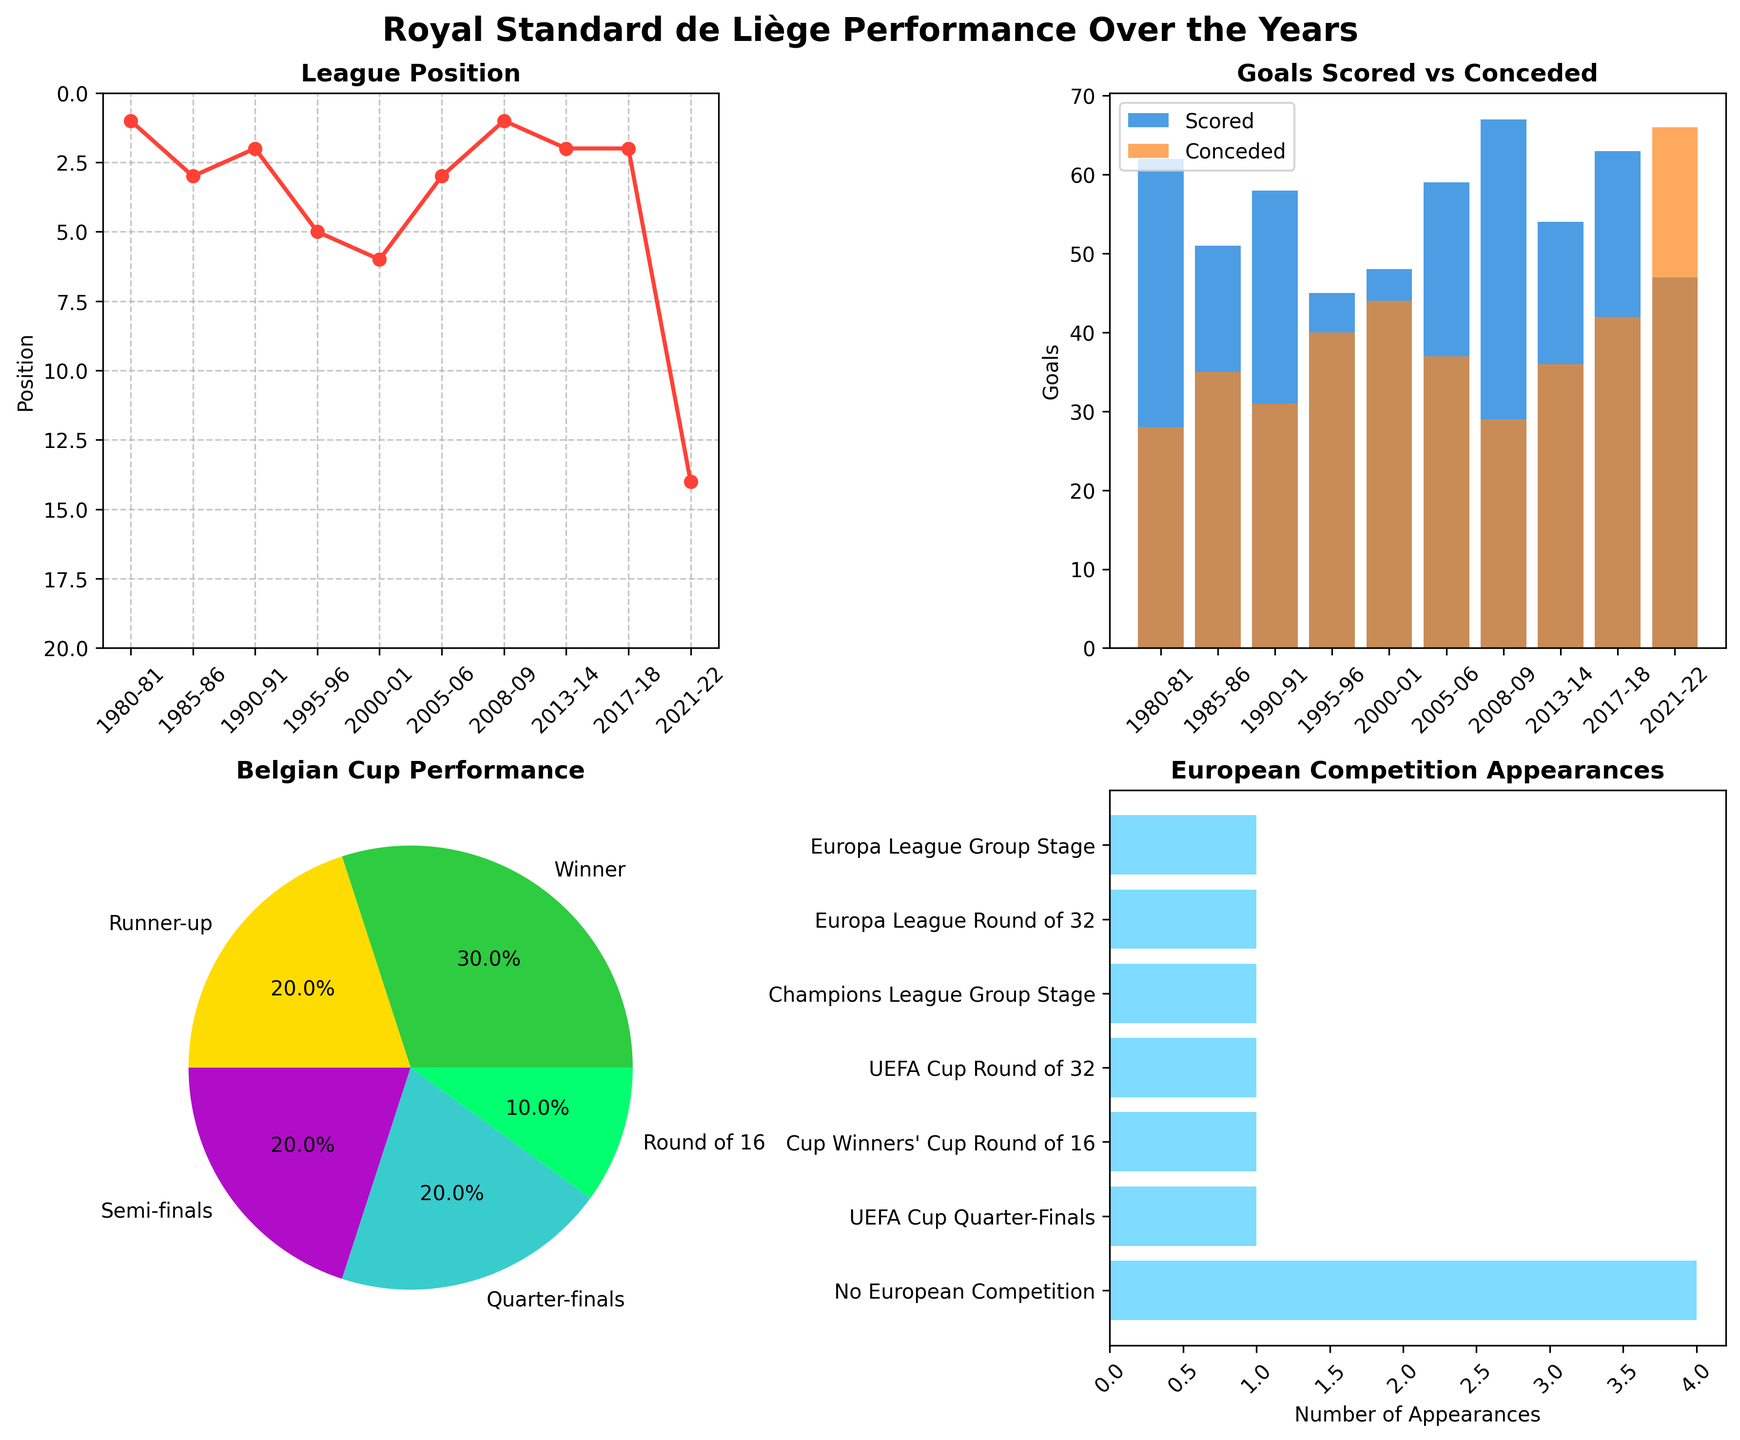What season did Royal Standard de Liège finish 14th in the league? The line plot for the 'League Position' subplot shows that the 14th position corresponds to the season 2021-22.
Answer: 2021-22 How many goals did Royal Standard de Liège score in the 2008-09 season? Referring to the 'Goals Scored vs Conceded' bar plot, the bar for 'Goals Scored' in the 2008-09 season reaches up to 67.
Answer: 67 Which Belgian Cup performance category has the highest percentage? The 'Belgian Cup Performance' pie chart shows each category and their percentages, with 'Runner-up' having the highest visually apparent percentage.
Answer: Runner-up How many times did Royal Standard de Liège win the Belgian Cup across the mentioned seasons? The pie chart for 'Belgian Cup Performance' shows the categories with their counts, and 'Winner' is a segment on the chart. By counting the number of occurrences, 'Winner' appears twice.
Answer: 2 times Which season had the highest number of goals conceded? From the 'Goals Scored vs Conceded' bar plot, the bar for goals conceded is highest during the 2021-22 season, reaching 66.
Answer: 2021-22 How many seasons did Royal Standard de Liège compete in European competitions? The 'European Competition Appearances' horizontal bar chart displays the total counts for each type of competition. Sum all bars except 'No European Competition' to get the total: (2 + 2 + 1 = 5).
Answer: 5 seasons Compare the league position in the seasons 1980-81 and 2008-09. Which season had a better league finish? The 'League Position' plot shows that 1st place was achieved in both 1980-81 and 2008-09. Thus, both seasons had the best possible finish.
Answer: Both seasons had the best finish Out of all the seasons displayed, in how many did Royal Standard de Liège not participate in any European competition? From the 'European Competition Appearances' horizontal bar chart, referring to 'No European Competition' shows the count of such seasons and it's 4.
Answer: 4 seasons What seasons did the club reach the semi-finals in the Belgian Cup? Looking at the categories in the 'Belgian Cup Performance' pie chart, 'Semi-finals' is visible, and cross-referencing with the 'Season' column, it corresponds with the 1990-91 and 2013-14 seasons.
Answer: 1990-91 and 2013-14 